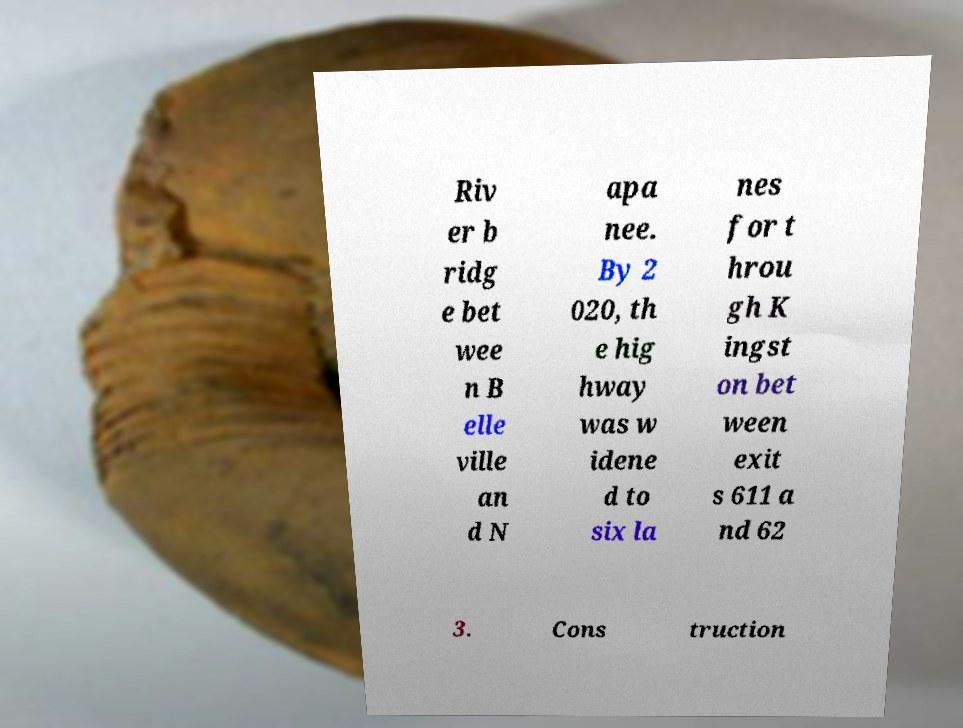Can you read and provide the text displayed in the image?This photo seems to have some interesting text. Can you extract and type it out for me? Riv er b ridg e bet wee n B elle ville an d N apa nee. By 2 020, th e hig hway was w idene d to six la nes for t hrou gh K ingst on bet ween exit s 611 a nd 62 3. Cons truction 